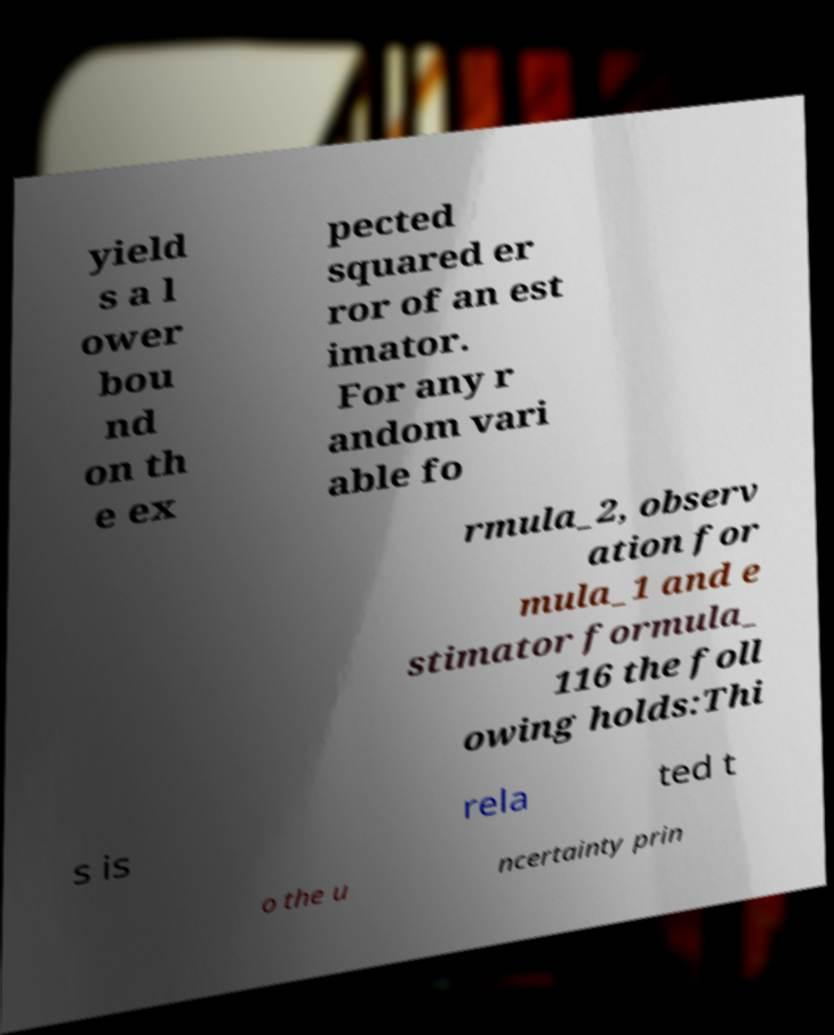Please identify and transcribe the text found in this image. yield s a l ower bou nd on th e ex pected squared er ror of an est imator. For any r andom vari able fo rmula_2, observ ation for mula_1 and e stimator formula_ 116 the foll owing holds:Thi s is rela ted t o the u ncertainty prin 